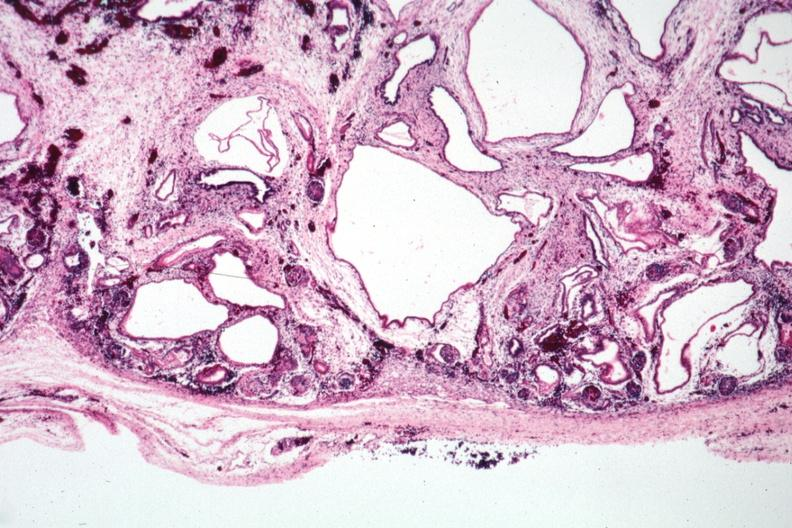what is present?
Answer the question using a single word or phrase. Polycystic disease infant 